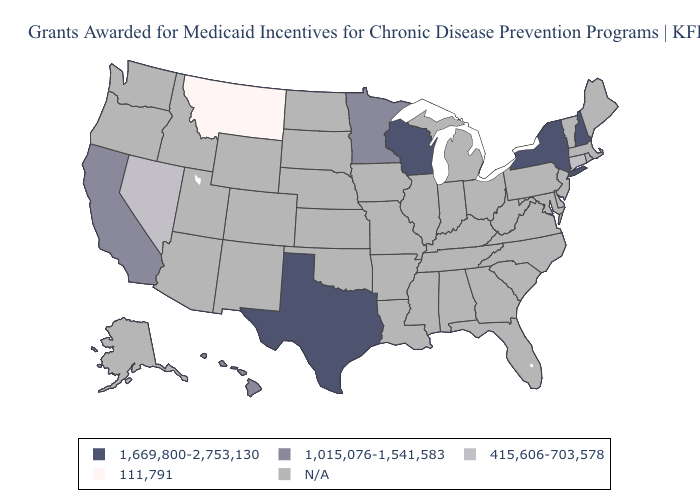What is the highest value in the Northeast ?
Give a very brief answer. 1,669,800-2,753,130. Name the states that have a value in the range 111,791?
Write a very short answer. Montana. Does Texas have the highest value in the USA?
Concise answer only. Yes. What is the value of Kansas?
Be succinct. N/A. What is the value of Utah?
Short answer required. N/A. What is the value of Florida?
Keep it brief. N/A. Does the map have missing data?
Keep it brief. Yes. Which states have the lowest value in the MidWest?
Short answer required. Minnesota. What is the highest value in the Northeast ?
Concise answer only. 1,669,800-2,753,130. Name the states that have a value in the range 1,669,800-2,753,130?
Write a very short answer. New Hampshire, New York, Texas, Wisconsin. Does New York have the highest value in the USA?
Answer briefly. Yes. Is the legend a continuous bar?
Give a very brief answer. No. What is the value of Louisiana?
Short answer required. N/A. What is the lowest value in states that border Minnesota?
Concise answer only. 1,669,800-2,753,130. 